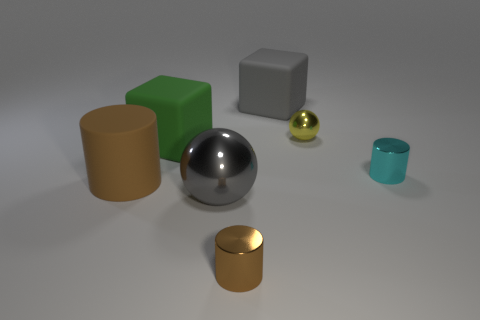How many objects are big objects left of the large gray ball or brown matte things?
Your answer should be compact. 2. The other metal thing that is the same shape as the large metal object is what color?
Make the answer very short. Yellow. Is the shape of the small yellow metallic object the same as the big gray object right of the brown metal cylinder?
Keep it short and to the point. No. How many things are objects to the left of the green cube or rubber cubes that are in front of the gray cube?
Offer a very short reply. 2. Are there fewer large green things that are to the right of the yellow metal ball than large blue metal objects?
Your response must be concise. No. Is the material of the big sphere the same as the brown thing right of the brown rubber object?
Offer a terse response. Yes. What is the small yellow thing made of?
Offer a very short reply. Metal. There is a brown cylinder on the left side of the cube that is to the left of the small metallic cylinder in front of the big brown rubber cylinder; what is it made of?
Give a very brief answer. Rubber. Does the rubber cylinder have the same color as the metallic cylinder that is in front of the small cyan thing?
Provide a succinct answer. Yes. Is there any other thing that has the same shape as the big green matte object?
Make the answer very short. Yes. 